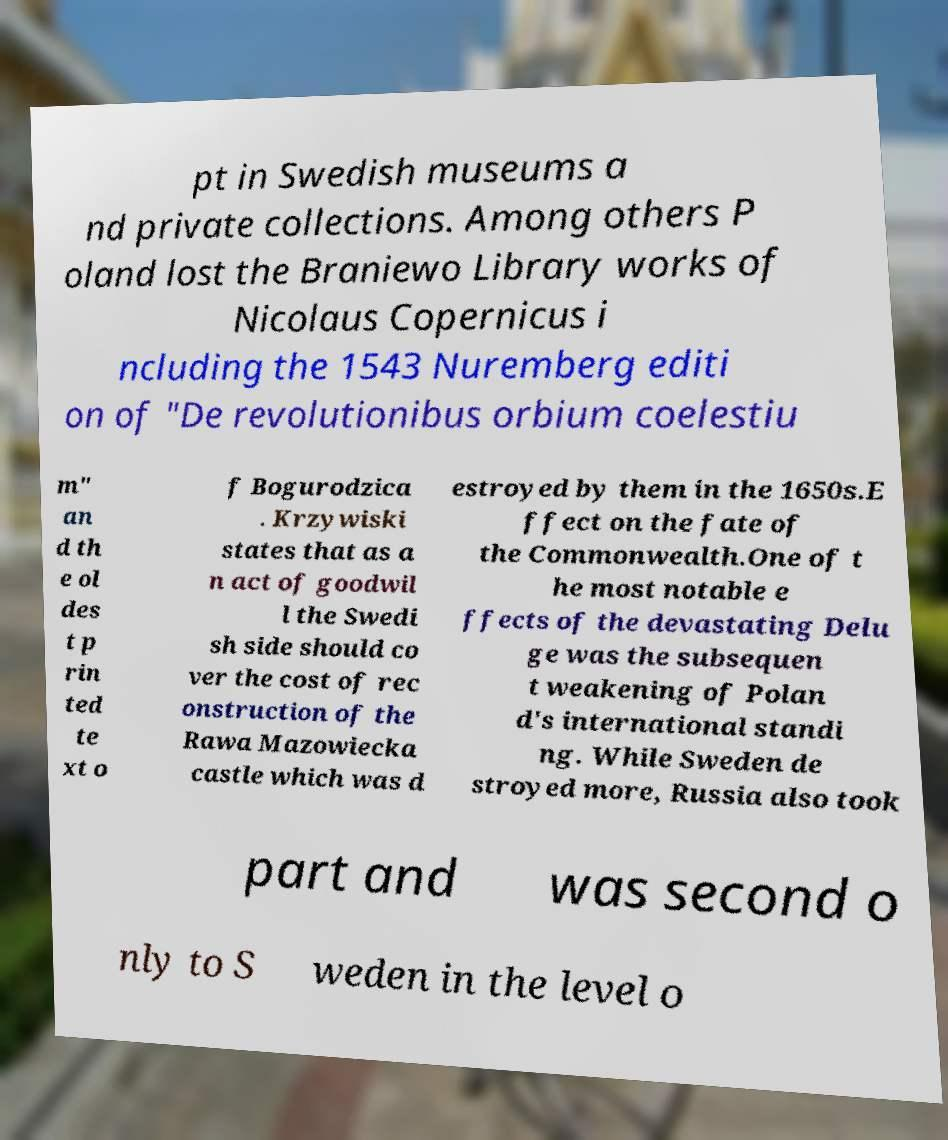For documentation purposes, I need the text within this image transcribed. Could you provide that? pt in Swedish museums a nd private collections. Among others P oland lost the Braniewo Library works of Nicolaus Copernicus i ncluding the 1543 Nuremberg editi on of "De revolutionibus orbium coelestiu m" an d th e ol des t p rin ted te xt o f Bogurodzica . Krzywiski states that as a n act of goodwil l the Swedi sh side should co ver the cost of rec onstruction of the Rawa Mazowiecka castle which was d estroyed by them in the 1650s.E ffect on the fate of the Commonwealth.One of t he most notable e ffects of the devastating Delu ge was the subsequen t weakening of Polan d's international standi ng. While Sweden de stroyed more, Russia also took part and was second o nly to S weden in the level o 